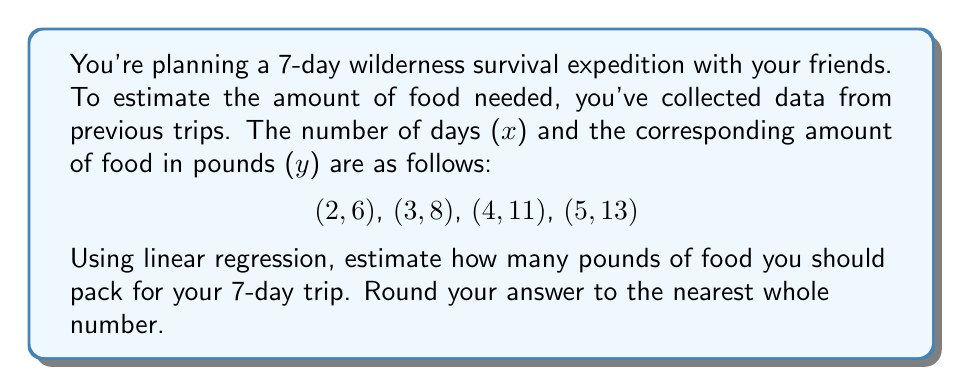Can you solve this math problem? Let's approach this step-by-step using linear regression:

1) First, we need to find the equation of the line of best fit in the form $y = mx + b$, where $m$ is the slope and $b$ is the y-intercept.

2) To find $m$ and $b$, we'll use these formulas:

   $m = \frac{n\sum xy - \sum x \sum y}{n\sum x^2 - (\sum x)^2}$

   $b = \frac{\sum y - m\sum x}{n}$

   where $n$ is the number of data points.

3) Let's calculate the sums we need:
   $n = 4$
   $\sum x = 2 + 3 + 4 + 5 = 14$
   $\sum y = 6 + 8 + 11 + 13 = 38$
   $\sum xy = (2)(6) + (3)(8) + (4)(11) + (5)(13) = 12 + 24 + 44 + 65 = 145$
   $\sum x^2 = 2^2 + 3^2 + 4^2 + 5^2 = 4 + 9 + 16 + 25 = 54$

4) Now let's calculate $m$:

   $m = \frac{4(145) - (14)(38)}{4(54) - (14)^2} = \frac{580 - 532}{216 - 196} = \frac{48}{20} = 2.4$

5) And now $b$:

   $b = \frac{38 - 2.4(14)}{4} = \frac{38 - 33.6}{4} = \frac{4.4}{4} = 1.1$

6) So our line of best fit is $y = 2.4x + 1.1$

7) To estimate the amount of food for 7 days, we plug in $x = 7$:

   $y = 2.4(7) + 1.1 = 16.8 + 1.1 = 17.9$

8) Rounding to the nearest whole number, we get 18.
Answer: 18 pounds of food 